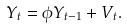Convert formula to latex. <formula><loc_0><loc_0><loc_500><loc_500>Y _ { t } = \phi Y _ { t - 1 } + V _ { t } .</formula> 